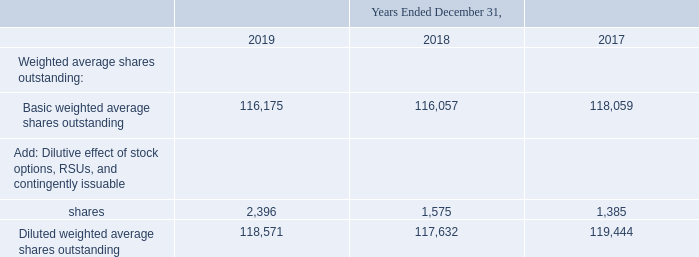8. Earnings Per Share
Basic earnings per share is computed in accordance with ASC 260, Earnings per Share, based on weighted average outstanding common shares. Diluted earnings per share is computed based on basic weighted average outstanding common shares adjusted for the dilutive effect of stock options, RSUs, and certain contingently issuable shares for which performance targets have been achieved.
The following table reconciles the weighted average share amounts used to compute both basic and diluted earnings per share (in thousands):
The diluted earnings per share computation excludes 1.8 million, 2.2 million, and 3.9 million options to purchase shares, RSUs, and contingently issuable shares during the years ended December 31, 2019, 2018, and 2017, respectively, as their effect would be antidilutive.
Common stock outstanding as of December 31, 2019 and 2018, was 115,986,352 and 116,123,361, respectively.
How were basic earnings per share computed by the company? In accordance with asc 260, earnings per share, based on weighted average outstanding common shares. How were diluted earnings per share computed by the company? Based on basic weighted average outstanding common shares adjusted for the dilutive effect of stock options, rsus, and certain contingently issuable shares for which performance targets have been achieved. What was the basic weighted average shares outstanding in 2019?
Answer scale should be: thousand. 116,175. What was the change in Basic weighted average shares outstanding between 2018 and 2019?
Answer scale should be: thousand. 116,175-116,057
Answer: 118. What was the change in Basic weighted average shares outstanding between 2017 and 2018?
Answer scale should be: thousand. 116,057-118,059
Answer: -2002. What was the percentage change in Diluted weighted average shares outstanding between 2018 and 2019?
Answer scale should be: percent. (118,571-117,632)/117,632
Answer: 0.8. 